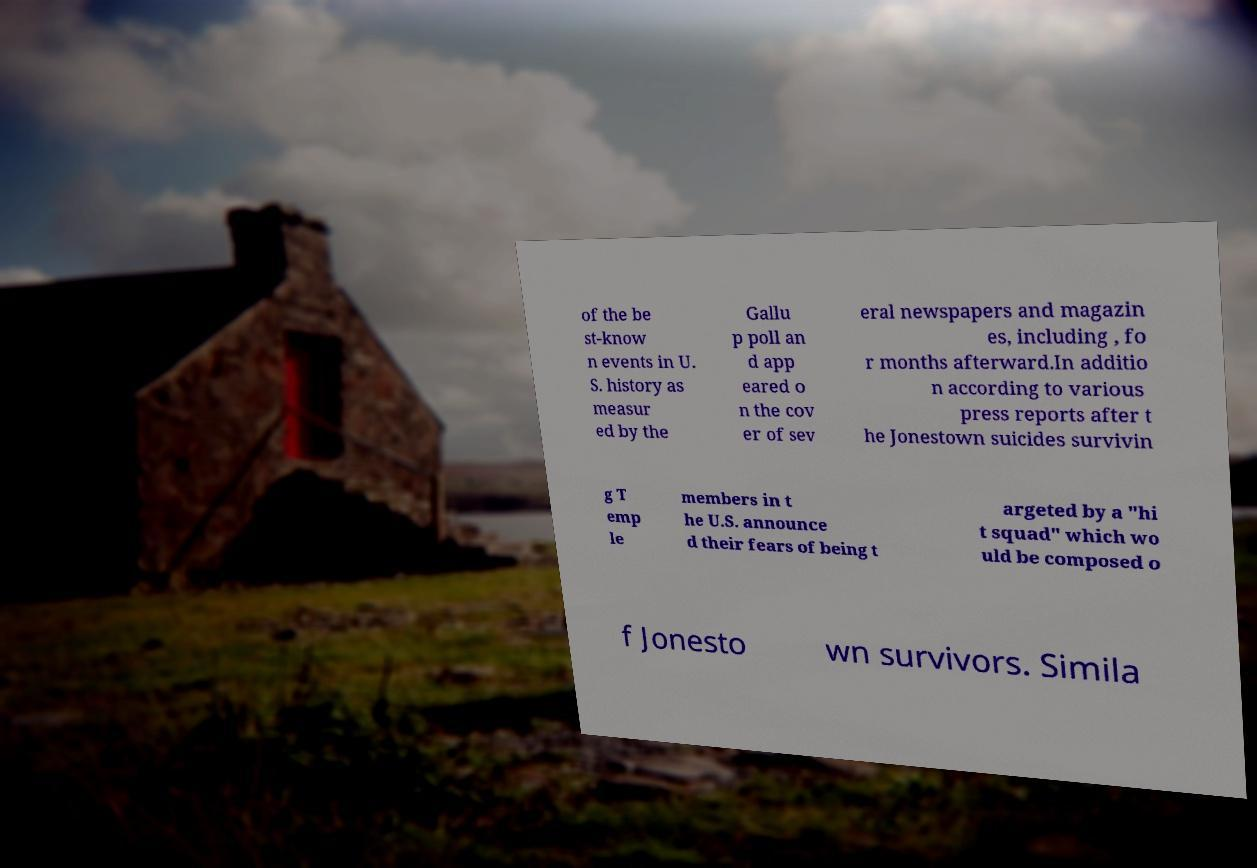What messages or text are displayed in this image? I need them in a readable, typed format. of the be st-know n events in U. S. history as measur ed by the Gallu p poll an d app eared o n the cov er of sev eral newspapers and magazin es, including , fo r months afterward.In additio n according to various press reports after t he Jonestown suicides survivin g T emp le members in t he U.S. announce d their fears of being t argeted by a "hi t squad" which wo uld be composed o f Jonesto wn survivors. Simila 